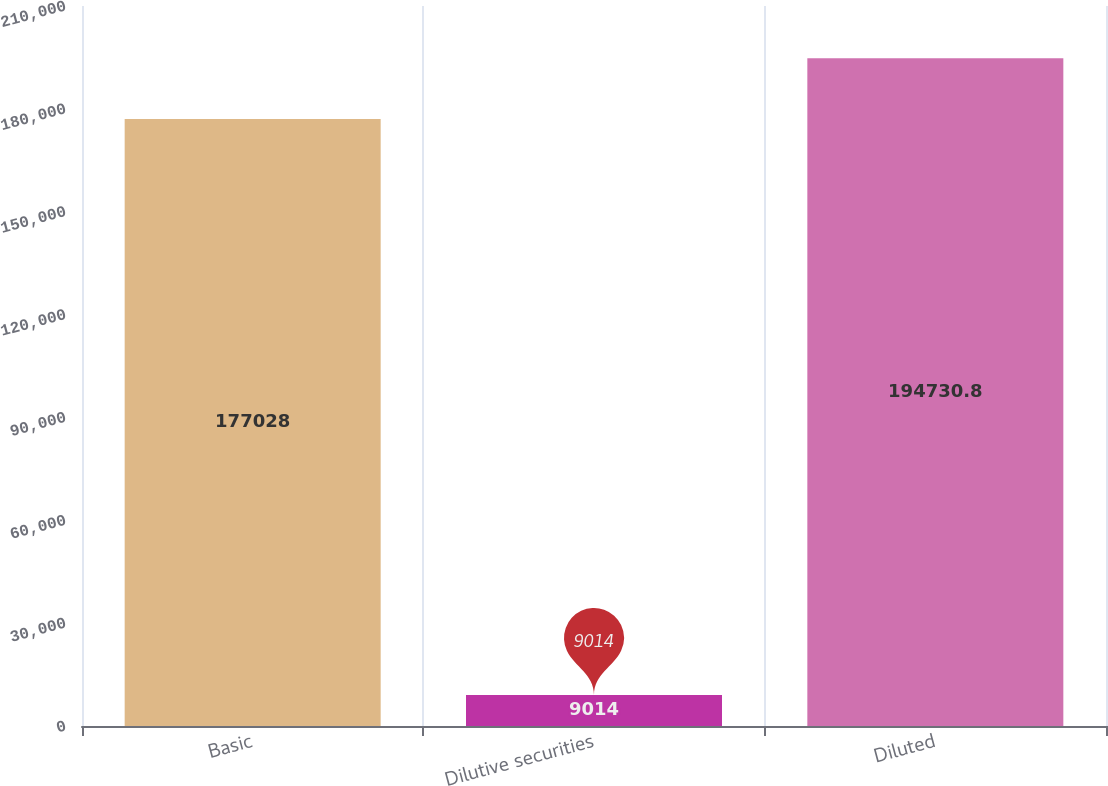<chart> <loc_0><loc_0><loc_500><loc_500><bar_chart><fcel>Basic<fcel>Dilutive securities<fcel>Diluted<nl><fcel>177028<fcel>9014<fcel>194731<nl></chart> 